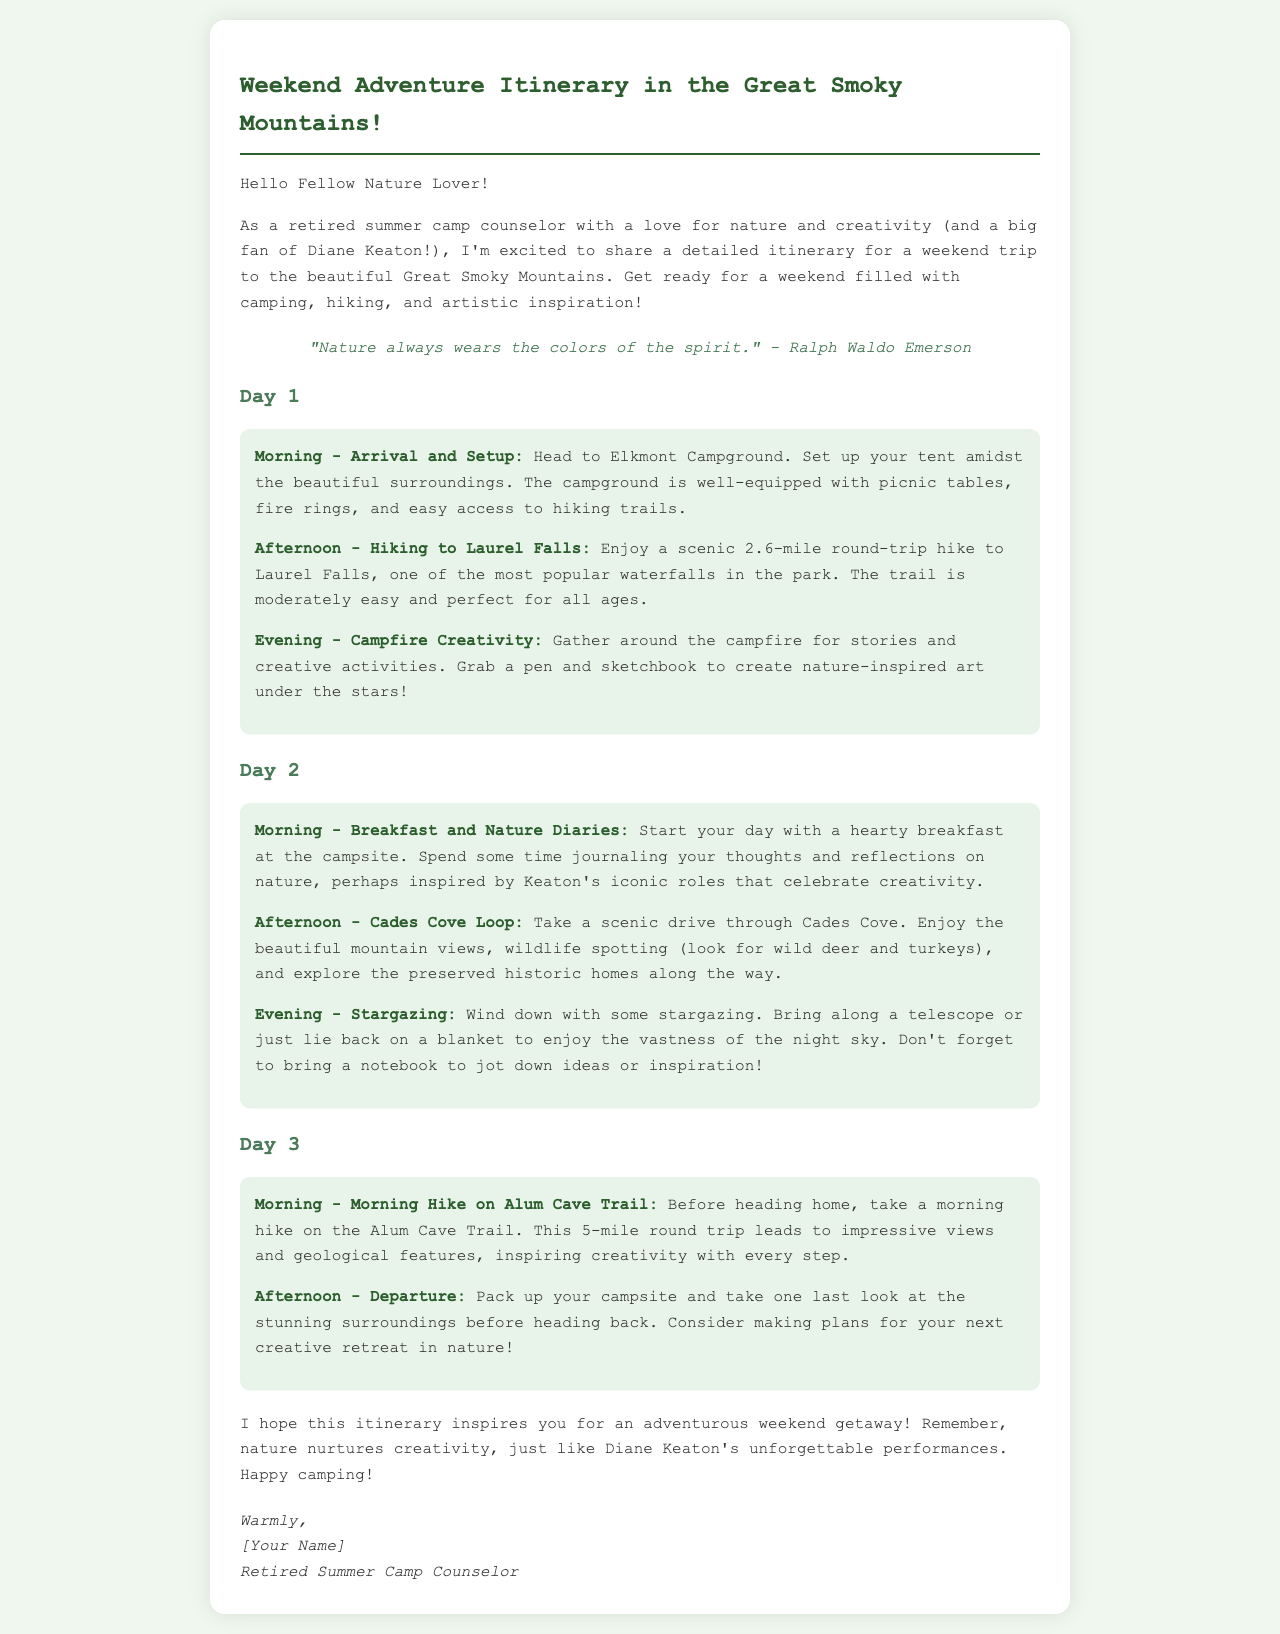what is the title of the itinerary? The title of the itinerary is presented at the beginning of the document.
Answer: Weekend Adventure Itinerary in the Great Smoky Mountains! what is the name of the campground mentioned? The name of the campground is specified in the morning activity of Day 1.
Answer: Elkmont Campground how long is the hike to Laurel Falls? The distance of the hike to Laurel Falls can be found in the afternoon activity of Day 1.
Answer: 2.6 miles what is the main activity during the evening of Day 1? The primary activity during the evening of Day 1 is detailed in the related section.
Answer: Campfire Creativity which trail is suggested for a morning hike on Day 3? The name of the trail for the morning hike on Day 3 is found in the corresponding section.
Answer: Alum Cave Trail what is one nearby attraction mentioned in the itinerary? The itinerary includes a scenic drive as an attraction on Day 2.
Answer: Cades Cove what type of writing activity is suggested for the morning of Day 2? The recommended writing activity for the morning of Day 2 is described in the related activity.
Answer: Nature Diaries who is the author of the itinerary? The identification of the author is located at the end of the document in the signature.
Answer: [Your Name] 